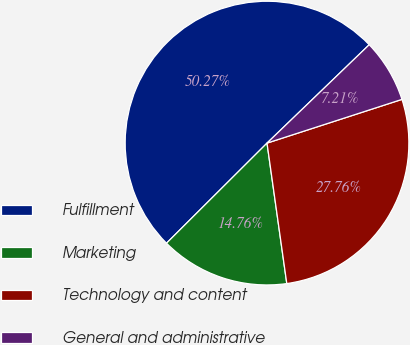Convert chart to OTSL. <chart><loc_0><loc_0><loc_500><loc_500><pie_chart><fcel>Fulfillment<fcel>Marketing<fcel>Technology and content<fcel>General and administrative<nl><fcel>50.27%<fcel>14.76%<fcel>27.76%<fcel>7.21%<nl></chart> 